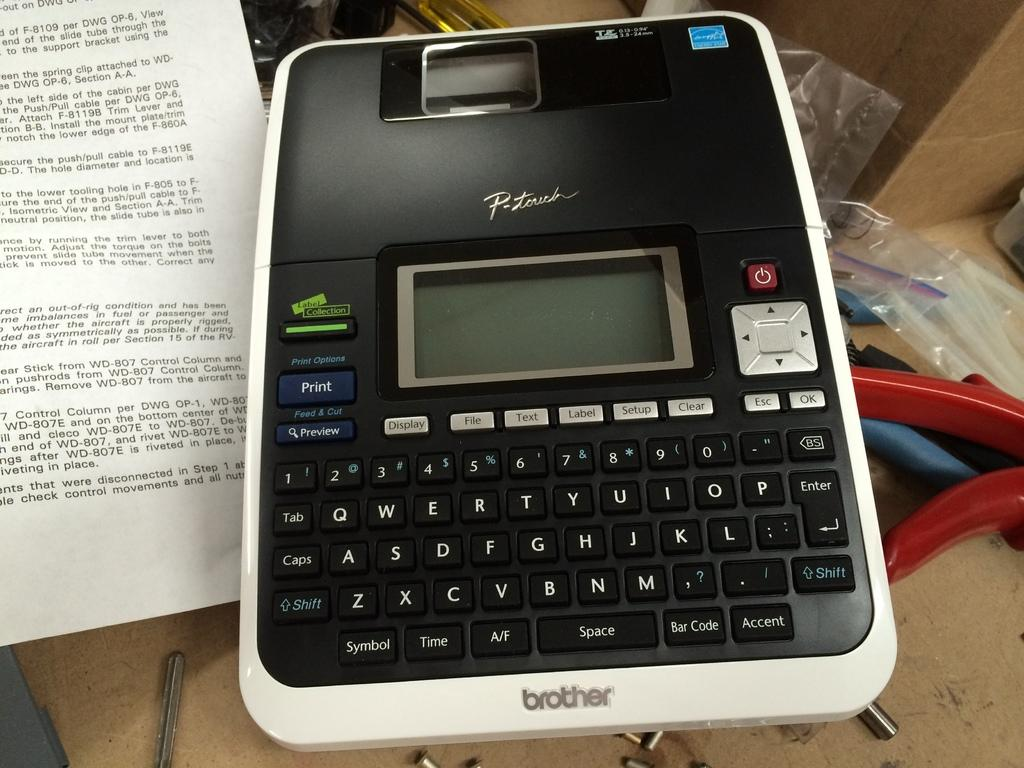<image>
Share a concise interpretation of the image provided. the word brother that is on a calculator 